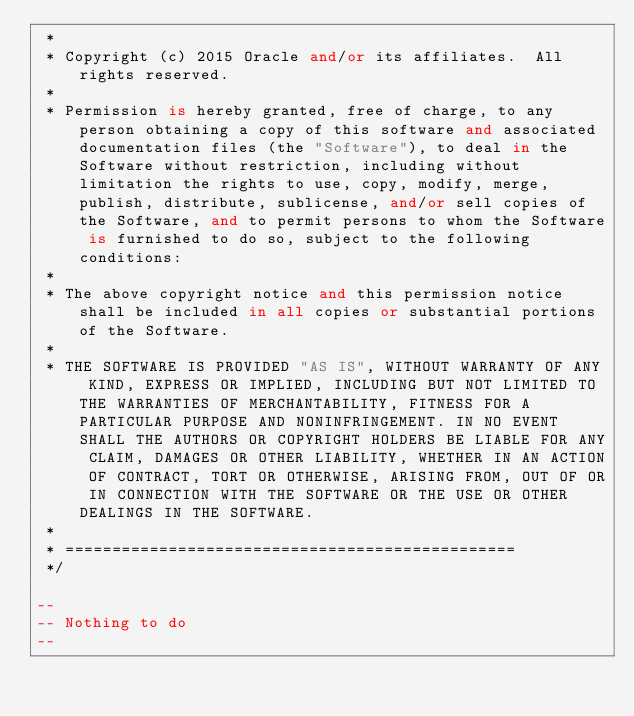<code> <loc_0><loc_0><loc_500><loc_500><_SQL_> *    
 * Copyright (c) 2015 Oracle and/or its affiliates.  All rights reserved.
 *
 * Permission is hereby granted, free of charge, to any person obtaining a copy of this software and associated documentation files (the "Software"), to deal in the Software without restriction, including without limitation the rights to use, copy, modify, merge, publish, distribute, sublicense, and/or sell copies of the Software, and to permit persons to whom the Software is furnished to do so, subject to the following conditions:
 *
 * The above copyright notice and this permission notice shall be included in all copies or substantial portions of the Software.
 *
 * THE SOFTWARE IS PROVIDED "AS IS", WITHOUT WARRANTY OF ANY KIND, EXPRESS OR IMPLIED, INCLUDING BUT NOT LIMITED TO THE WARRANTIES OF MERCHANTABILITY, FITNESS FOR A PARTICULAR PURPOSE AND NONINFRINGEMENT. IN NO EVENT SHALL THE AUTHORS OR COPYRIGHT HOLDERS BE LIABLE FOR ANY CLAIM, DAMAGES OR OTHER LIABILITY, WHETHER IN AN ACTION OF CONTRACT, TORT OR OTHERWISE, ARISING FROM, OUT OF OR IN CONNECTION WITH THE SOFTWARE OR THE USE OR OTHER DEALINGS IN THE SOFTWARE.
 *
 * ================================================
 */

--
-- Nothing to do
--</code> 